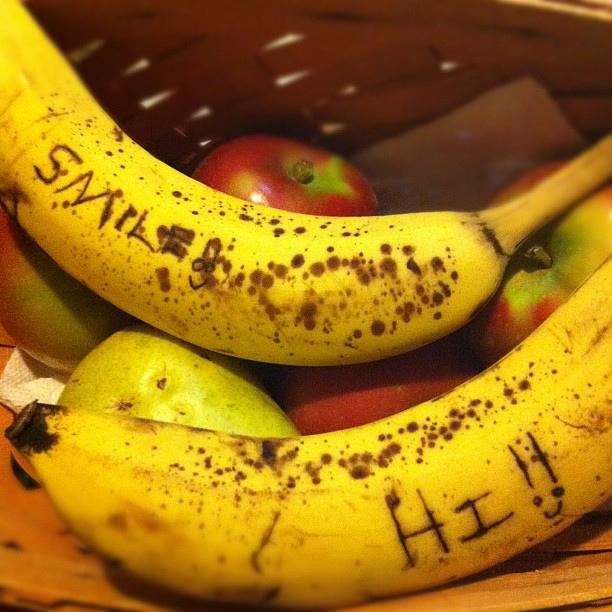What animal do the spots on the banana most resemble? giraffe 